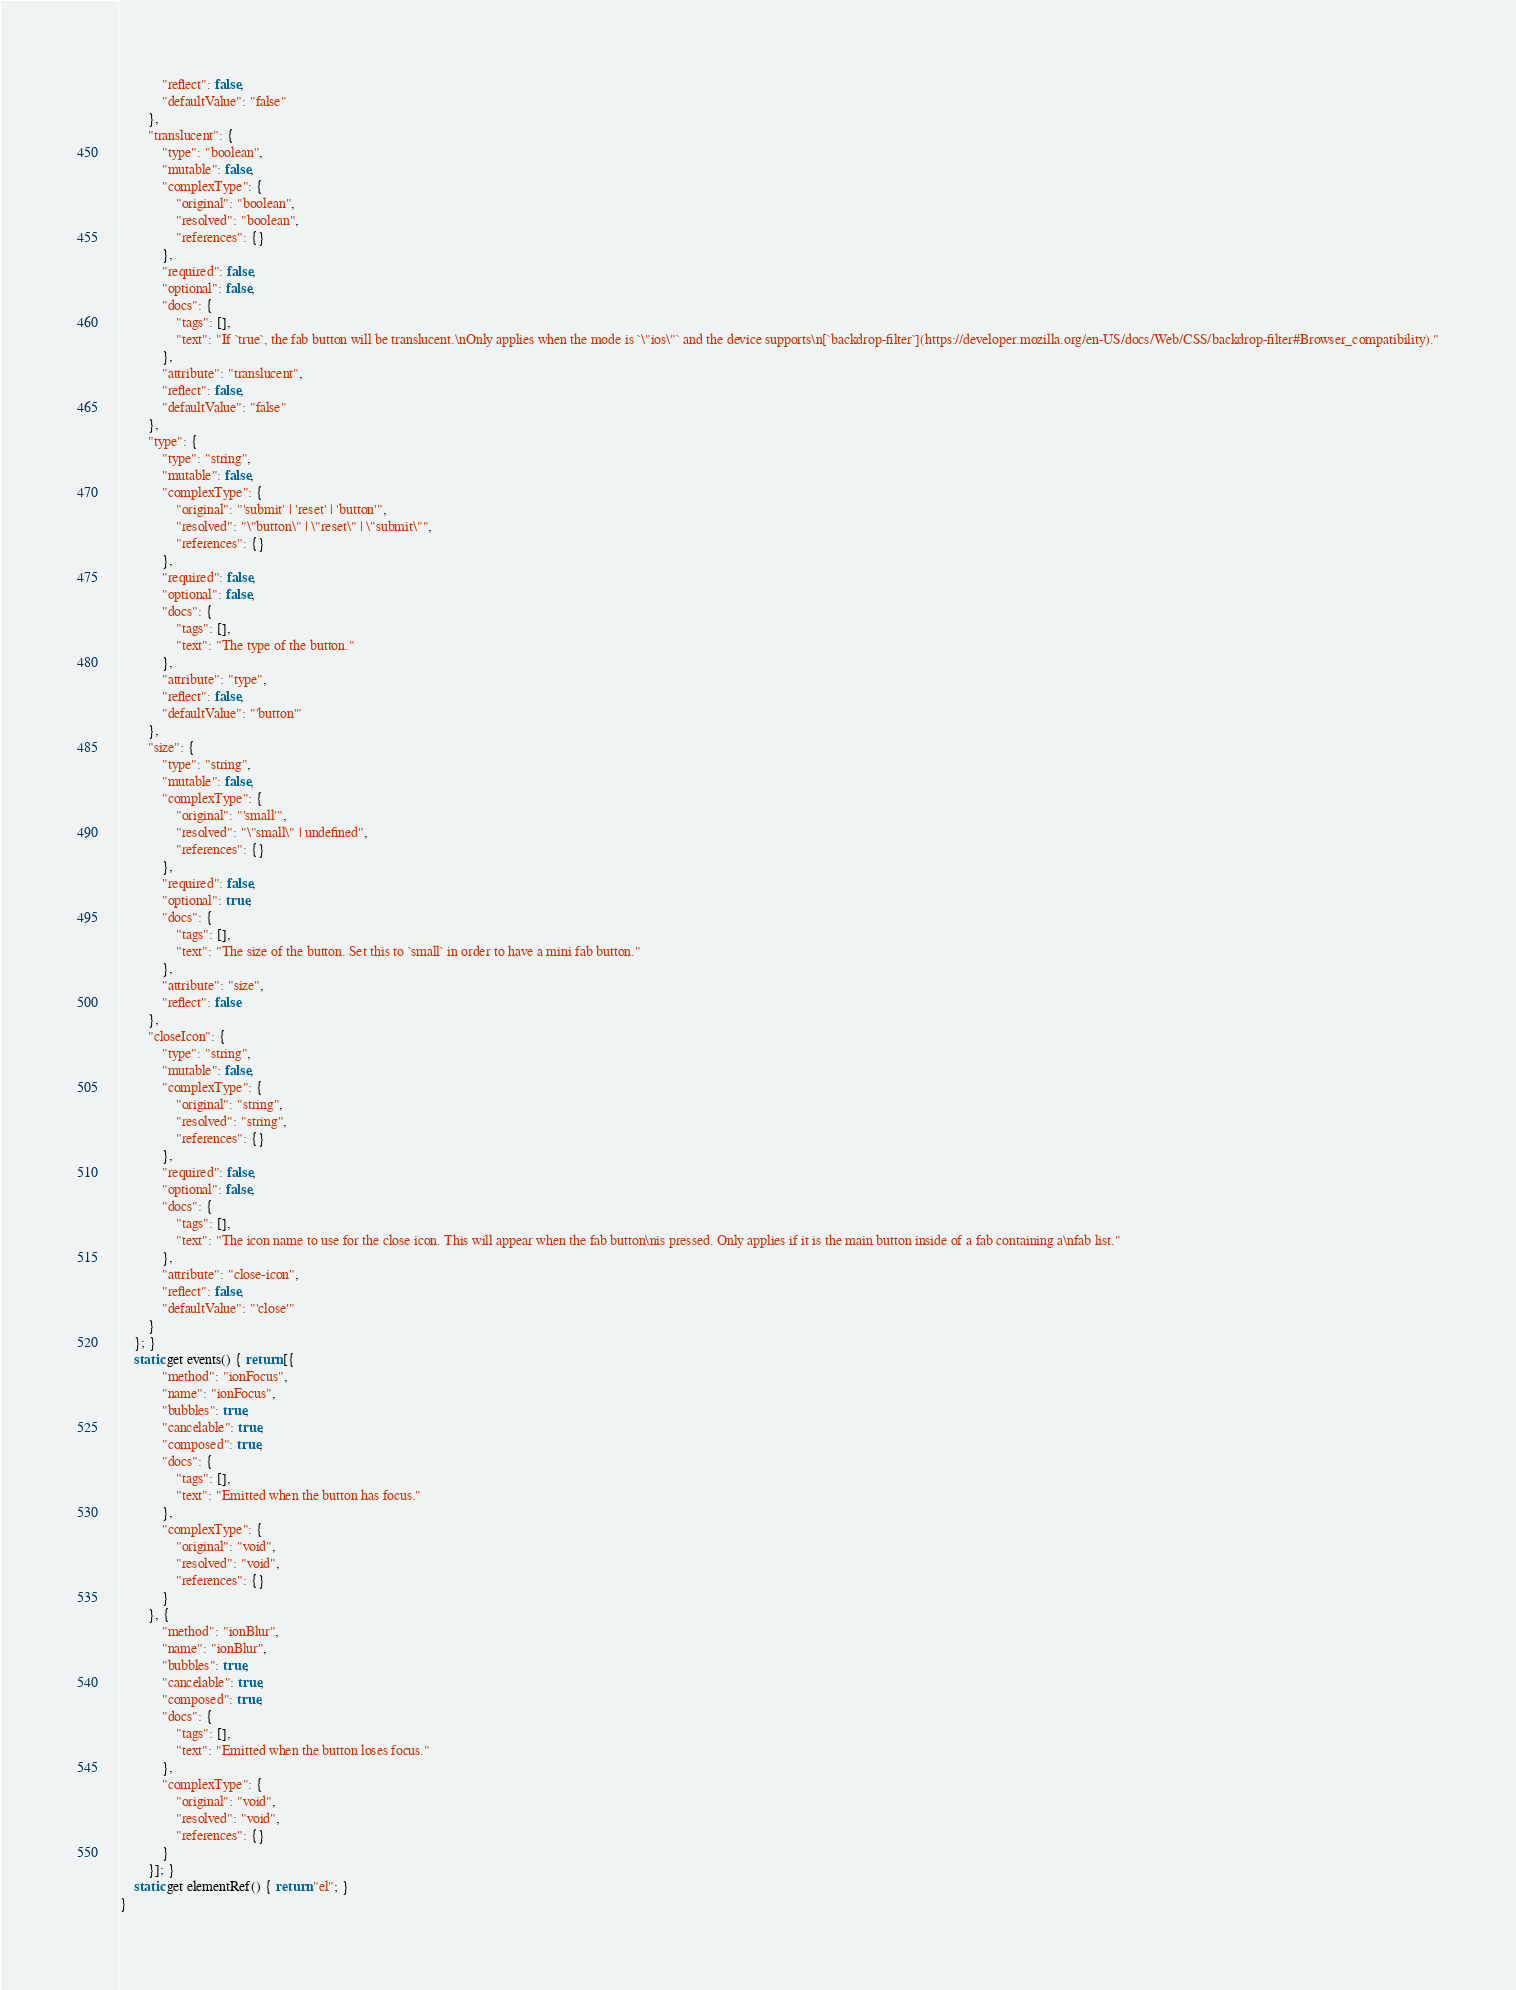Convert code to text. <code><loc_0><loc_0><loc_500><loc_500><_JavaScript_>            "reflect": false,
            "defaultValue": "false"
        },
        "translucent": {
            "type": "boolean",
            "mutable": false,
            "complexType": {
                "original": "boolean",
                "resolved": "boolean",
                "references": {}
            },
            "required": false,
            "optional": false,
            "docs": {
                "tags": [],
                "text": "If `true`, the fab button will be translucent.\nOnly applies when the mode is `\"ios\"` and the device supports\n[`backdrop-filter`](https://developer.mozilla.org/en-US/docs/Web/CSS/backdrop-filter#Browser_compatibility)."
            },
            "attribute": "translucent",
            "reflect": false,
            "defaultValue": "false"
        },
        "type": {
            "type": "string",
            "mutable": false,
            "complexType": {
                "original": "'submit' | 'reset' | 'button'",
                "resolved": "\"button\" | \"reset\" | \"submit\"",
                "references": {}
            },
            "required": false,
            "optional": false,
            "docs": {
                "tags": [],
                "text": "The type of the button."
            },
            "attribute": "type",
            "reflect": false,
            "defaultValue": "'button'"
        },
        "size": {
            "type": "string",
            "mutable": false,
            "complexType": {
                "original": "'small'",
                "resolved": "\"small\" | undefined",
                "references": {}
            },
            "required": false,
            "optional": true,
            "docs": {
                "tags": [],
                "text": "The size of the button. Set this to `small` in order to have a mini fab button."
            },
            "attribute": "size",
            "reflect": false
        },
        "closeIcon": {
            "type": "string",
            "mutable": false,
            "complexType": {
                "original": "string",
                "resolved": "string",
                "references": {}
            },
            "required": false,
            "optional": false,
            "docs": {
                "tags": [],
                "text": "The icon name to use for the close icon. This will appear when the fab button\nis pressed. Only applies if it is the main button inside of a fab containing a\nfab list."
            },
            "attribute": "close-icon",
            "reflect": false,
            "defaultValue": "'close'"
        }
    }; }
    static get events() { return [{
            "method": "ionFocus",
            "name": "ionFocus",
            "bubbles": true,
            "cancelable": true,
            "composed": true,
            "docs": {
                "tags": [],
                "text": "Emitted when the button has focus."
            },
            "complexType": {
                "original": "void",
                "resolved": "void",
                "references": {}
            }
        }, {
            "method": "ionBlur",
            "name": "ionBlur",
            "bubbles": true,
            "cancelable": true,
            "composed": true,
            "docs": {
                "tags": [],
                "text": "Emitted when the button loses focus."
            },
            "complexType": {
                "original": "void",
                "resolved": "void",
                "references": {}
            }
        }]; }
    static get elementRef() { return "el"; }
}
</code> 